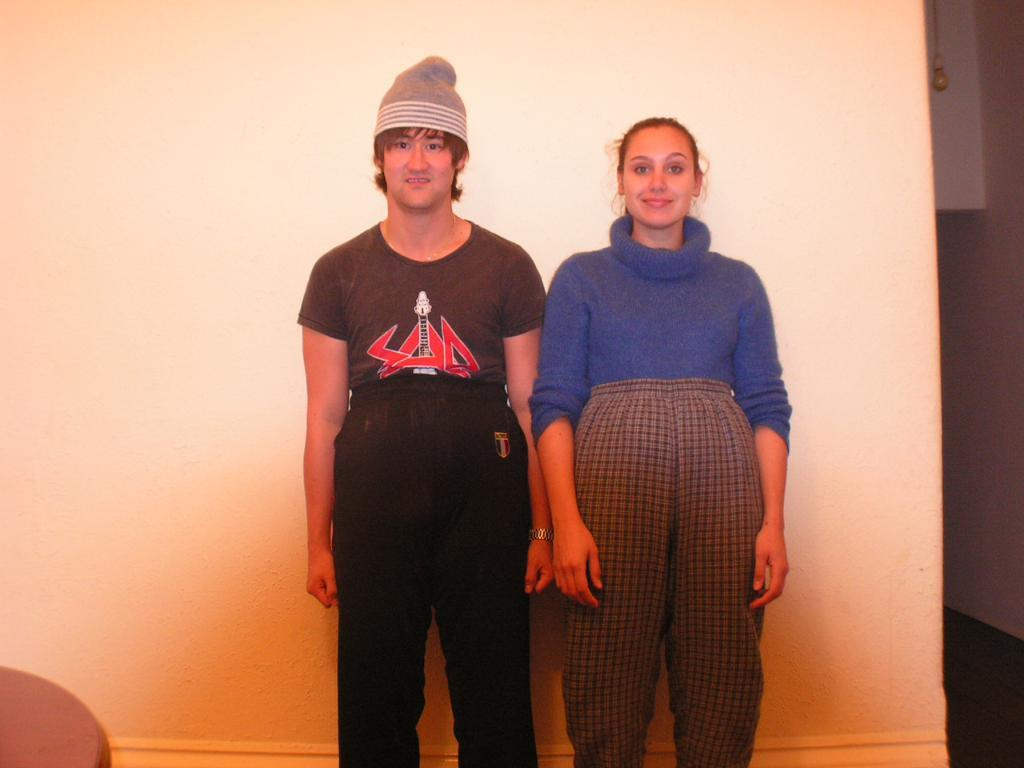Who are the people in the image? There is a man and a woman in the image. What are the man and woman doing in the image? The man and woman are standing beside a wall. What can be seen on the right side of the image? There is a bulb hanged with a rope on the right side of the image. What is present at the bottom left of the image? There is an object on the left bottom of the image. What type of store can be seen in the background of the image? There is no store visible in the image; it only shows a man, a woman, a wall, a bulb, and an object on the left bottom. 